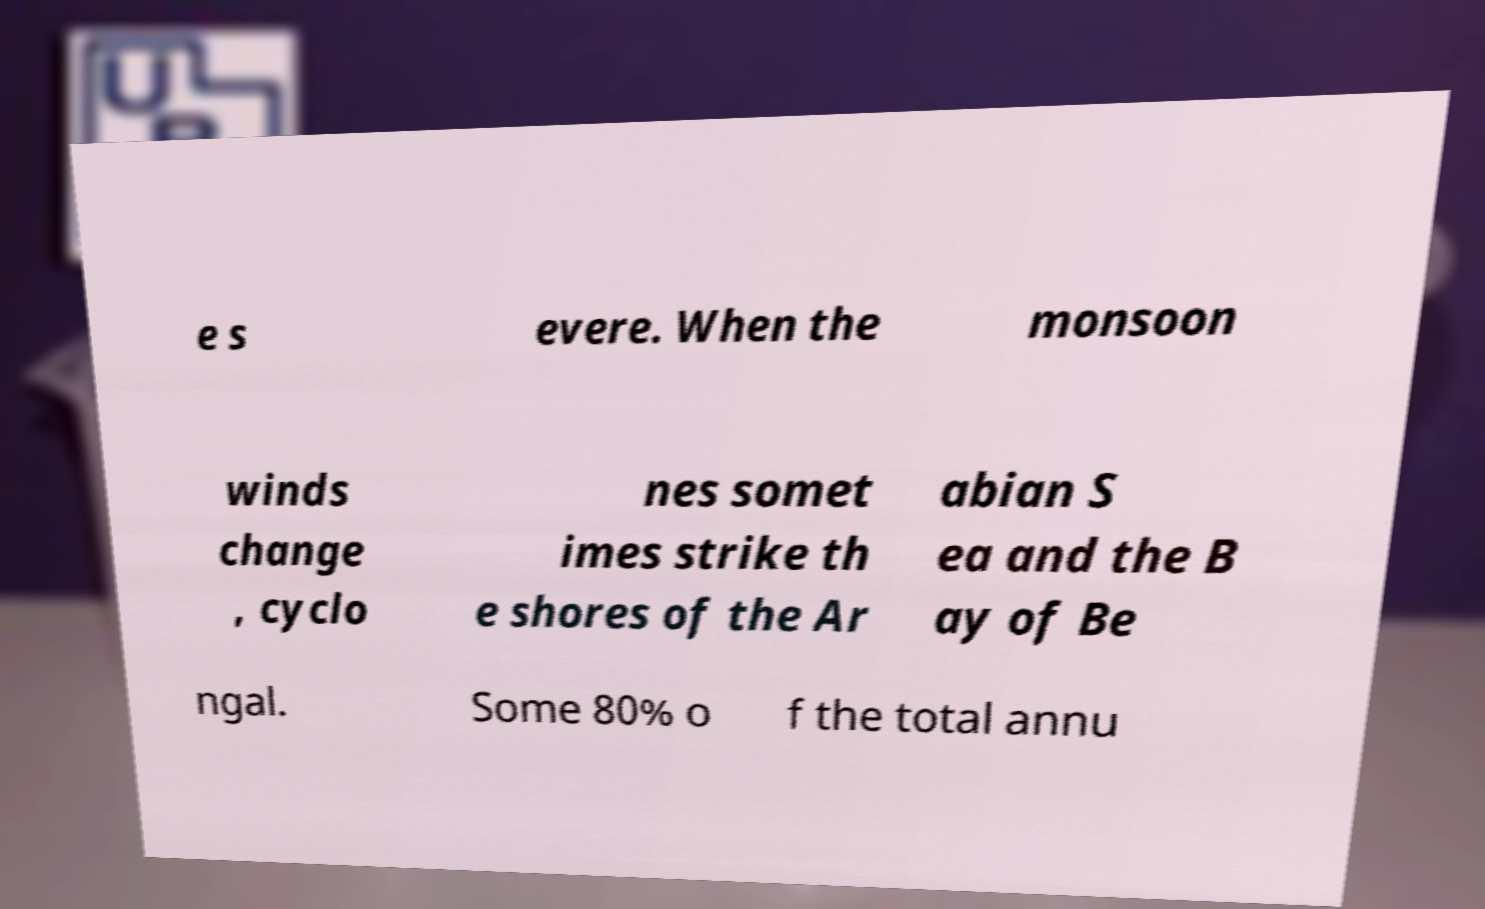Could you assist in decoding the text presented in this image and type it out clearly? e s evere. When the monsoon winds change , cyclo nes somet imes strike th e shores of the Ar abian S ea and the B ay of Be ngal. Some 80% o f the total annu 